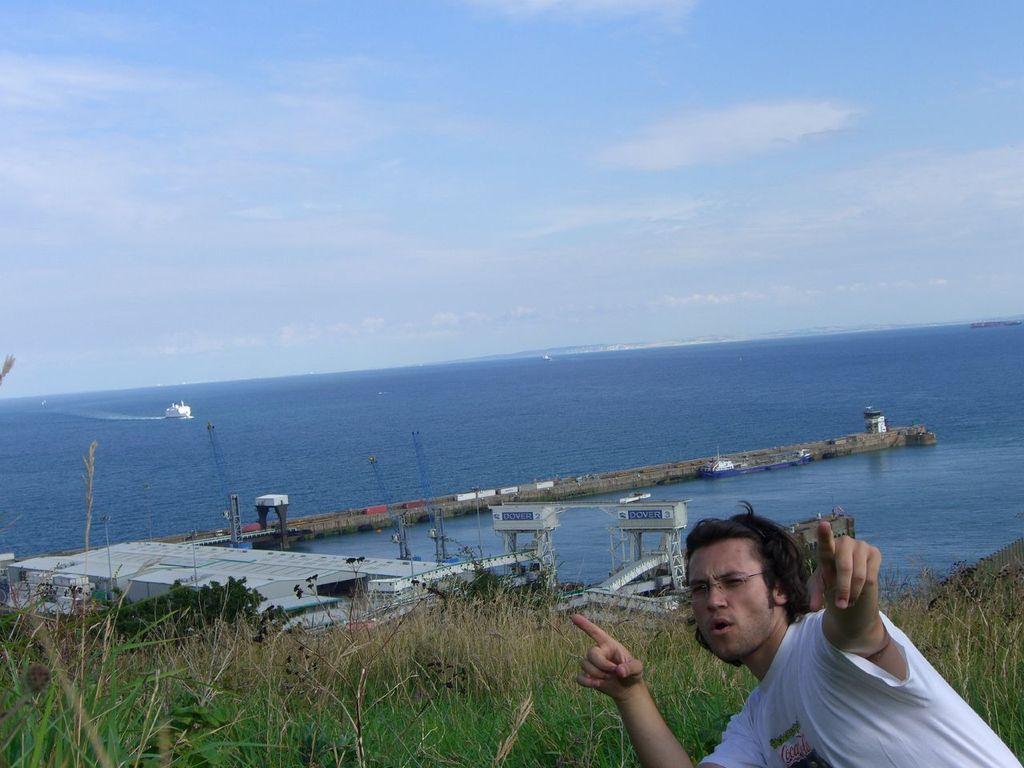Can you describe this image briefly? In this picture I can see a man with spectacles, there is grass, there are trees, there is a pier and a building, there is a ship on the water, and in the background there is sky. 